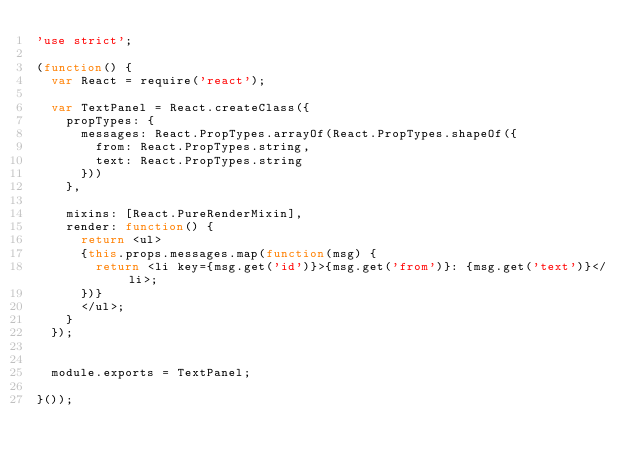<code> <loc_0><loc_0><loc_500><loc_500><_JavaScript_>'use strict';

(function() {
  var React = require('react');

  var TextPanel = React.createClass({
    propTypes: {
      messages: React.PropTypes.arrayOf(React.PropTypes.shapeOf({
        from: React.PropTypes.string,
        text: React.PropTypes.string
      }))
    },

    mixins: [React.PureRenderMixin],
    render: function() {
      return <ul>
      {this.props.messages.map(function(msg) {
        return <li key={msg.get('id')}>{msg.get('from')}: {msg.get('text')}</li>;
      })}
      </ul>;
    }
  });


  module.exports = TextPanel;

}());
</code> 